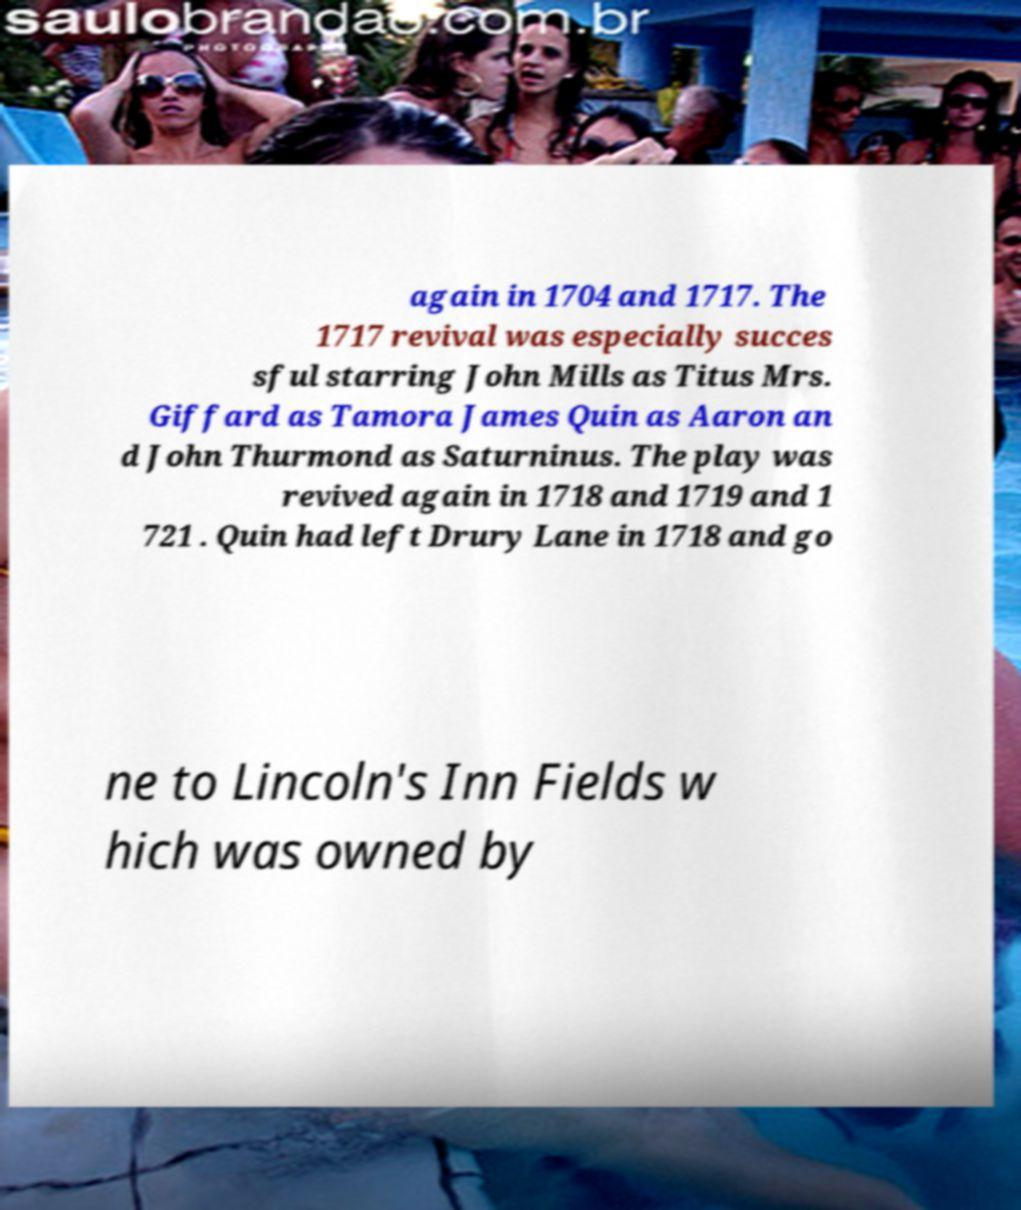Could you assist in decoding the text presented in this image and type it out clearly? again in 1704 and 1717. The 1717 revival was especially succes sful starring John Mills as Titus Mrs. Giffard as Tamora James Quin as Aaron an d John Thurmond as Saturninus. The play was revived again in 1718 and 1719 and 1 721 . Quin had left Drury Lane in 1718 and go ne to Lincoln's Inn Fields w hich was owned by 